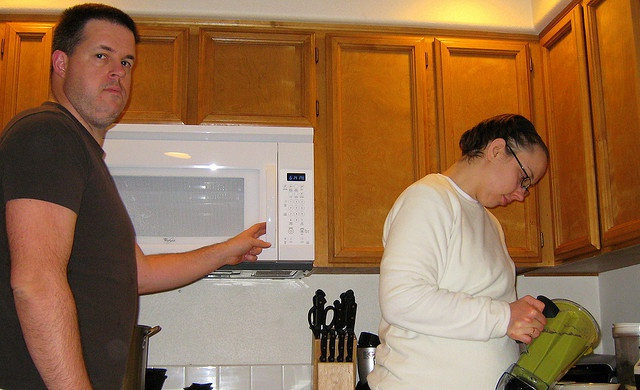Describe the objects in this image and their specific colors. I can see people in gold, black, brown, and maroon tones, people in gold, lightgray, salmon, and darkgray tones, microwave in gold, darkgray, and lightgray tones, scissors in gold, black, darkgray, gray, and lightgray tones, and knife in gold, black, olive, gray, and darkgray tones in this image. 